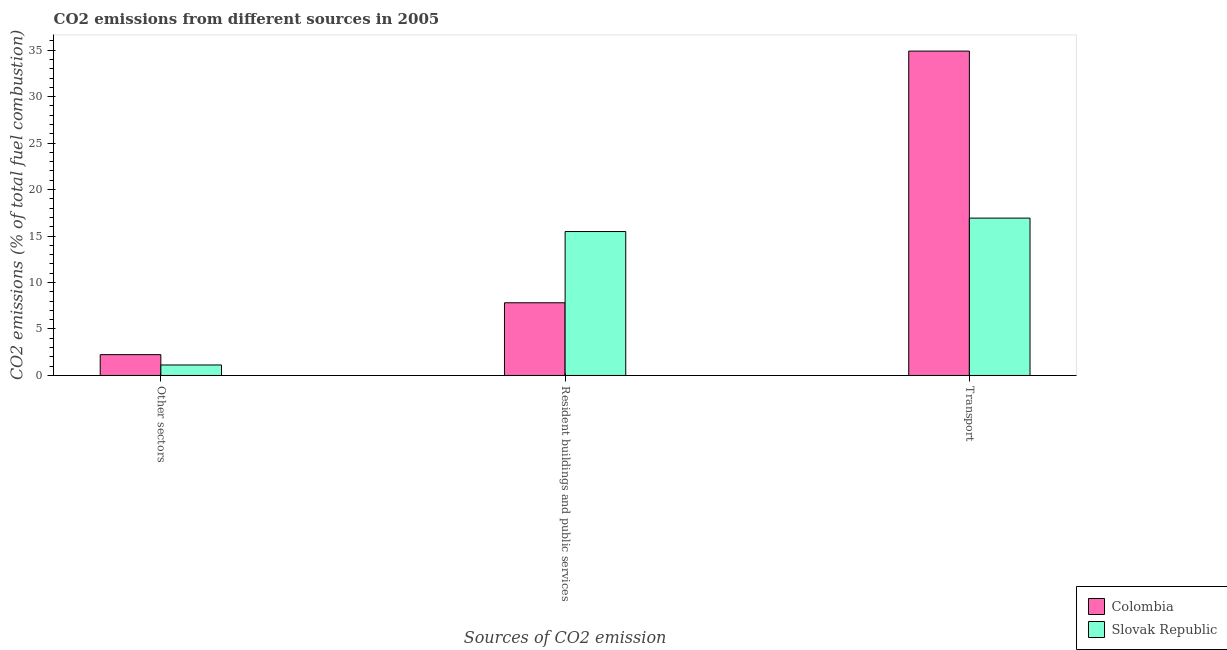How many groups of bars are there?
Keep it short and to the point. 3. Are the number of bars per tick equal to the number of legend labels?
Make the answer very short. Yes. Are the number of bars on each tick of the X-axis equal?
Keep it short and to the point. Yes. How many bars are there on the 1st tick from the left?
Offer a very short reply. 2. How many bars are there on the 1st tick from the right?
Make the answer very short. 2. What is the label of the 3rd group of bars from the left?
Your answer should be compact. Transport. What is the percentage of co2 emissions from other sectors in Colombia?
Ensure brevity in your answer.  2.24. Across all countries, what is the maximum percentage of co2 emissions from resident buildings and public services?
Give a very brief answer. 15.49. Across all countries, what is the minimum percentage of co2 emissions from resident buildings and public services?
Give a very brief answer. 7.82. In which country was the percentage of co2 emissions from transport minimum?
Make the answer very short. Slovak Republic. What is the total percentage of co2 emissions from other sectors in the graph?
Keep it short and to the point. 3.37. What is the difference between the percentage of co2 emissions from other sectors in Colombia and that in Slovak Republic?
Give a very brief answer. 1.11. What is the difference between the percentage of co2 emissions from transport in Colombia and the percentage of co2 emissions from resident buildings and public services in Slovak Republic?
Provide a short and direct response. 19.42. What is the average percentage of co2 emissions from resident buildings and public services per country?
Your response must be concise. 11.65. What is the difference between the percentage of co2 emissions from resident buildings and public services and percentage of co2 emissions from transport in Slovak Republic?
Give a very brief answer. -1.44. In how many countries, is the percentage of co2 emissions from resident buildings and public services greater than 16 %?
Your answer should be compact. 0. What is the ratio of the percentage of co2 emissions from other sectors in Slovak Republic to that in Colombia?
Your answer should be compact. 0.5. Is the difference between the percentage of co2 emissions from resident buildings and public services in Slovak Republic and Colombia greater than the difference between the percentage of co2 emissions from transport in Slovak Republic and Colombia?
Provide a succinct answer. Yes. What is the difference between the highest and the second highest percentage of co2 emissions from resident buildings and public services?
Provide a succinct answer. 7.66. What is the difference between the highest and the lowest percentage of co2 emissions from transport?
Give a very brief answer. 17.97. Is the sum of the percentage of co2 emissions from other sectors in Colombia and Slovak Republic greater than the maximum percentage of co2 emissions from resident buildings and public services across all countries?
Your answer should be very brief. No. What does the 2nd bar from the left in Transport represents?
Offer a terse response. Slovak Republic. What does the 1st bar from the right in Transport represents?
Keep it short and to the point. Slovak Republic. Are all the bars in the graph horizontal?
Ensure brevity in your answer.  No. What is the difference between two consecutive major ticks on the Y-axis?
Provide a short and direct response. 5. Does the graph contain grids?
Ensure brevity in your answer.  No. How many legend labels are there?
Make the answer very short. 2. How are the legend labels stacked?
Your answer should be compact. Vertical. What is the title of the graph?
Provide a short and direct response. CO2 emissions from different sources in 2005. What is the label or title of the X-axis?
Provide a succinct answer. Sources of CO2 emission. What is the label or title of the Y-axis?
Keep it short and to the point. CO2 emissions (% of total fuel combustion). What is the CO2 emissions (% of total fuel combustion) of Colombia in Other sectors?
Ensure brevity in your answer.  2.24. What is the CO2 emissions (% of total fuel combustion) of Slovak Republic in Other sectors?
Keep it short and to the point. 1.13. What is the CO2 emissions (% of total fuel combustion) of Colombia in Resident buildings and public services?
Provide a short and direct response. 7.82. What is the CO2 emissions (% of total fuel combustion) of Slovak Republic in Resident buildings and public services?
Keep it short and to the point. 15.49. What is the CO2 emissions (% of total fuel combustion) in Colombia in Transport?
Ensure brevity in your answer.  34.9. What is the CO2 emissions (% of total fuel combustion) of Slovak Republic in Transport?
Provide a succinct answer. 16.93. Across all Sources of CO2 emission, what is the maximum CO2 emissions (% of total fuel combustion) of Colombia?
Ensure brevity in your answer.  34.9. Across all Sources of CO2 emission, what is the maximum CO2 emissions (% of total fuel combustion) of Slovak Republic?
Your answer should be very brief. 16.93. Across all Sources of CO2 emission, what is the minimum CO2 emissions (% of total fuel combustion) of Colombia?
Give a very brief answer. 2.24. Across all Sources of CO2 emission, what is the minimum CO2 emissions (% of total fuel combustion) of Slovak Republic?
Provide a succinct answer. 1.13. What is the total CO2 emissions (% of total fuel combustion) of Colombia in the graph?
Provide a short and direct response. 44.96. What is the total CO2 emissions (% of total fuel combustion) in Slovak Republic in the graph?
Give a very brief answer. 33.54. What is the difference between the CO2 emissions (% of total fuel combustion) in Colombia in Other sectors and that in Resident buildings and public services?
Offer a terse response. -5.58. What is the difference between the CO2 emissions (% of total fuel combustion) in Slovak Republic in Other sectors and that in Resident buildings and public services?
Your answer should be very brief. -14.36. What is the difference between the CO2 emissions (% of total fuel combustion) of Colombia in Other sectors and that in Transport?
Give a very brief answer. -32.66. What is the difference between the CO2 emissions (% of total fuel combustion) of Slovak Republic in Other sectors and that in Transport?
Provide a succinct answer. -15.8. What is the difference between the CO2 emissions (% of total fuel combustion) of Colombia in Resident buildings and public services and that in Transport?
Your answer should be very brief. -27.08. What is the difference between the CO2 emissions (% of total fuel combustion) in Slovak Republic in Resident buildings and public services and that in Transport?
Your answer should be very brief. -1.44. What is the difference between the CO2 emissions (% of total fuel combustion) of Colombia in Other sectors and the CO2 emissions (% of total fuel combustion) of Slovak Republic in Resident buildings and public services?
Provide a succinct answer. -13.25. What is the difference between the CO2 emissions (% of total fuel combustion) in Colombia in Other sectors and the CO2 emissions (% of total fuel combustion) in Slovak Republic in Transport?
Give a very brief answer. -14.69. What is the difference between the CO2 emissions (% of total fuel combustion) in Colombia in Resident buildings and public services and the CO2 emissions (% of total fuel combustion) in Slovak Republic in Transport?
Your answer should be compact. -9.11. What is the average CO2 emissions (% of total fuel combustion) in Colombia per Sources of CO2 emission?
Give a very brief answer. 14.99. What is the average CO2 emissions (% of total fuel combustion) in Slovak Republic per Sources of CO2 emission?
Ensure brevity in your answer.  11.18. What is the difference between the CO2 emissions (% of total fuel combustion) in Colombia and CO2 emissions (% of total fuel combustion) in Slovak Republic in Other sectors?
Your response must be concise. 1.11. What is the difference between the CO2 emissions (% of total fuel combustion) of Colombia and CO2 emissions (% of total fuel combustion) of Slovak Republic in Resident buildings and public services?
Your response must be concise. -7.66. What is the difference between the CO2 emissions (% of total fuel combustion) of Colombia and CO2 emissions (% of total fuel combustion) of Slovak Republic in Transport?
Provide a succinct answer. 17.97. What is the ratio of the CO2 emissions (% of total fuel combustion) in Colombia in Other sectors to that in Resident buildings and public services?
Keep it short and to the point. 0.29. What is the ratio of the CO2 emissions (% of total fuel combustion) of Slovak Republic in Other sectors to that in Resident buildings and public services?
Ensure brevity in your answer.  0.07. What is the ratio of the CO2 emissions (% of total fuel combustion) of Colombia in Other sectors to that in Transport?
Offer a very short reply. 0.06. What is the ratio of the CO2 emissions (% of total fuel combustion) of Slovak Republic in Other sectors to that in Transport?
Your answer should be very brief. 0.07. What is the ratio of the CO2 emissions (% of total fuel combustion) in Colombia in Resident buildings and public services to that in Transport?
Your answer should be compact. 0.22. What is the ratio of the CO2 emissions (% of total fuel combustion) of Slovak Republic in Resident buildings and public services to that in Transport?
Provide a short and direct response. 0.91. What is the difference between the highest and the second highest CO2 emissions (% of total fuel combustion) in Colombia?
Give a very brief answer. 27.08. What is the difference between the highest and the second highest CO2 emissions (% of total fuel combustion) in Slovak Republic?
Provide a short and direct response. 1.44. What is the difference between the highest and the lowest CO2 emissions (% of total fuel combustion) in Colombia?
Keep it short and to the point. 32.66. What is the difference between the highest and the lowest CO2 emissions (% of total fuel combustion) in Slovak Republic?
Give a very brief answer. 15.8. 